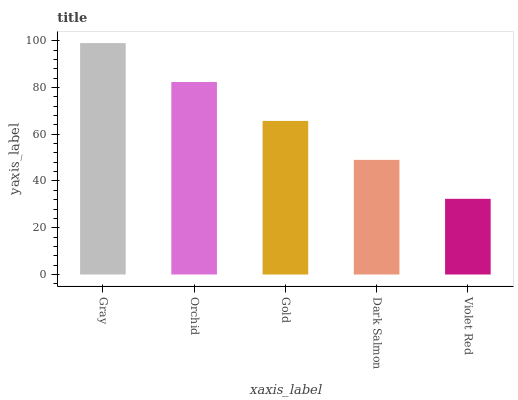Is Violet Red the minimum?
Answer yes or no. Yes. Is Gray the maximum?
Answer yes or no. Yes. Is Orchid the minimum?
Answer yes or no. No. Is Orchid the maximum?
Answer yes or no. No. Is Gray greater than Orchid?
Answer yes or no. Yes. Is Orchid less than Gray?
Answer yes or no. Yes. Is Orchid greater than Gray?
Answer yes or no. No. Is Gray less than Orchid?
Answer yes or no. No. Is Gold the high median?
Answer yes or no. Yes. Is Gold the low median?
Answer yes or no. Yes. Is Gray the high median?
Answer yes or no. No. Is Orchid the low median?
Answer yes or no. No. 